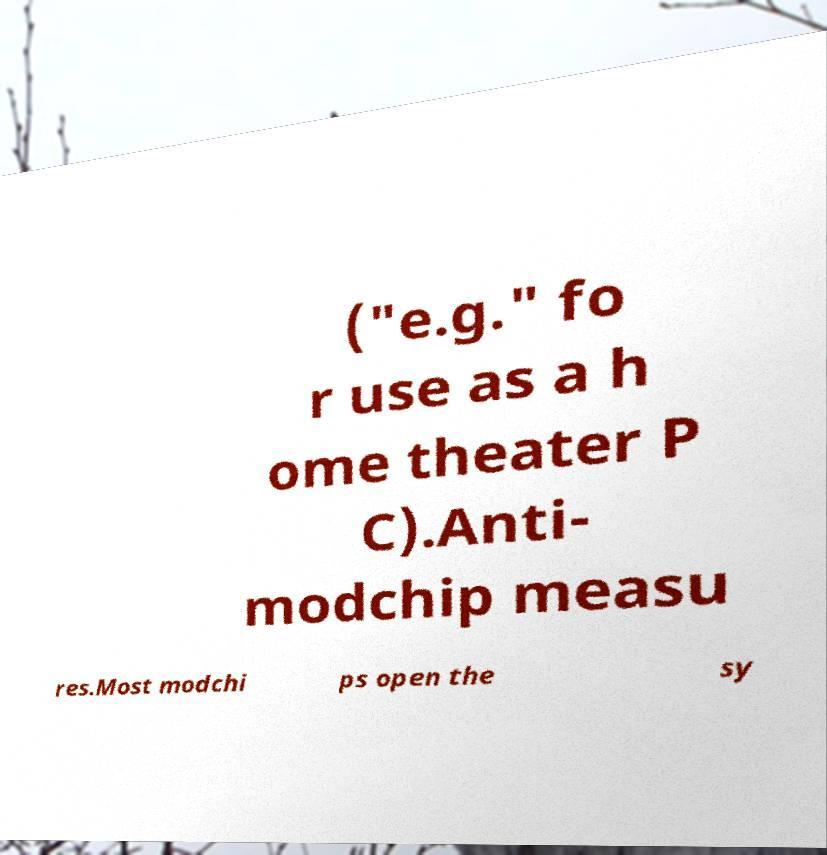Could you extract and type out the text from this image? ("e.g." fo r use as a h ome theater P C).Anti- modchip measu res.Most modchi ps open the sy 